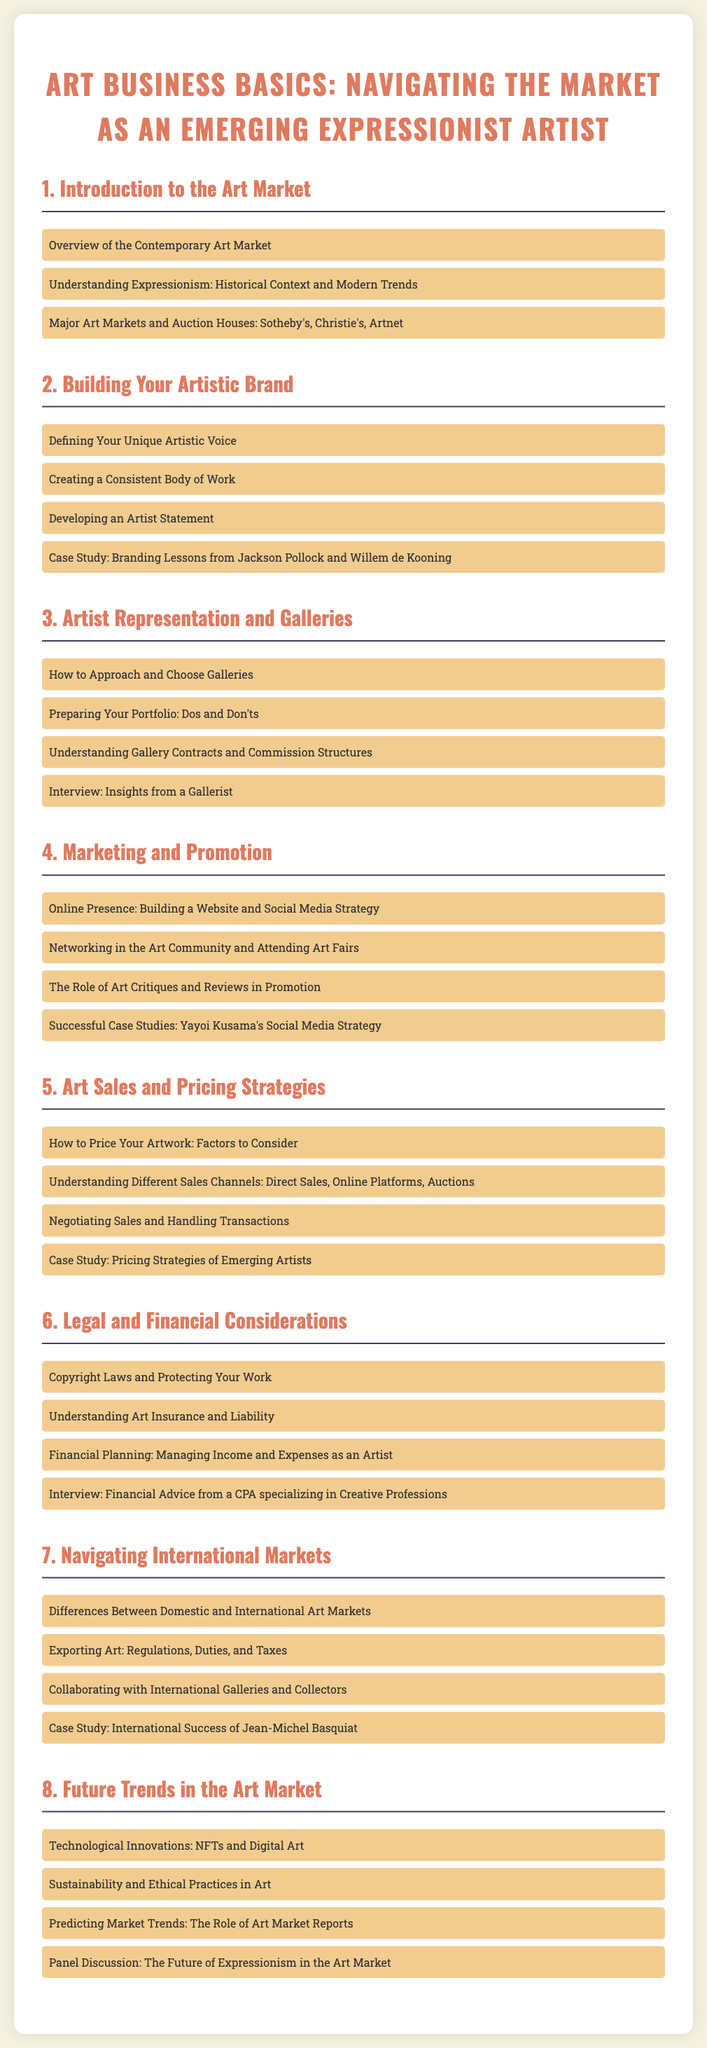what is the main title of the syllabus? The main title is stated at the top of the document, which encompasses the course focus for emerging artists.
Answer: Art Business Basics: Navigating the Market as an Emerging Expressionist Artist how many modules are in the syllabus? The total number of modules can be counted from the document, each focusing on a specific aspect of the art business.
Answer: 8 which module discusses "Developing an Artist Statement"? This topic appears under the section focused on building personal branding in art.
Answer: Building Your Artistic Brand who conducted the interview featured in the legal considerations module? The document states that an interview is included to provide expert financial advice relevant to artists.
Answer: a CPA specializing in Creative Professions what is a case study topic in the marketing module? The document references a successful artist's strategy to illustrate effective marketing practices in the art world.
Answer: Yayoi Kusama's Social Media Strategy what are the major art markets mentioned in the introduction module? This information highlights significant players in the global art marketplace relevant to the emerging artist's navigation of the trade.
Answer: Sotheby's, Christie's, Artnet which module focuses on pricing strategies? This module is dedicated to how artists can approach valuing and selling their work within the market.
Answer: Art Sales and Pricing Strategies what are two technological innovations discussed in the future trends module? The future of art is influenced by advancements that impact how art is created and sold, discussed in this module.
Answer: NFTs and Digital Art 